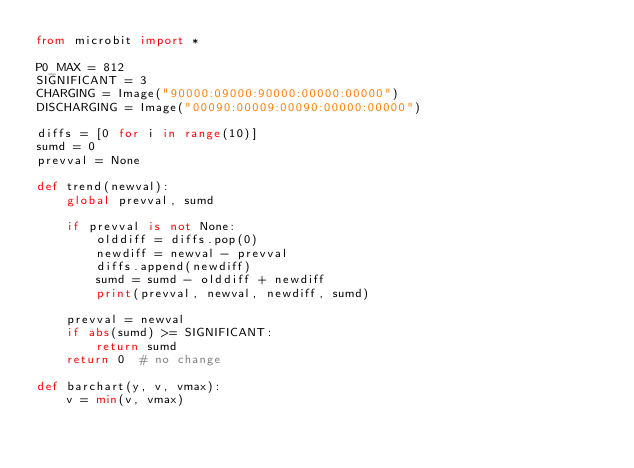<code> <loc_0><loc_0><loc_500><loc_500><_Python_>from microbit import *

P0_MAX = 812
SIGNIFICANT = 3
CHARGING = Image("90000:09000:90000:00000:00000")
DISCHARGING = Image("00090:00009:00090:00000:00000")

diffs = [0 for i in range(10)]
sumd = 0
prevval = None

def trend(newval):
    global prevval, sumd

    if prevval is not None:
        olddiff = diffs.pop(0)
        newdiff = newval - prevval
        diffs.append(newdiff)
        sumd = sumd - olddiff + newdiff
        print(prevval, newval, newdiff, sumd)
    
    prevval = newval
    if abs(sumd) >= SIGNIFICANT:
        return sumd
    return 0  # no change
    
def barchart(y, v, vmax):
    v = min(v, vmax)</code> 